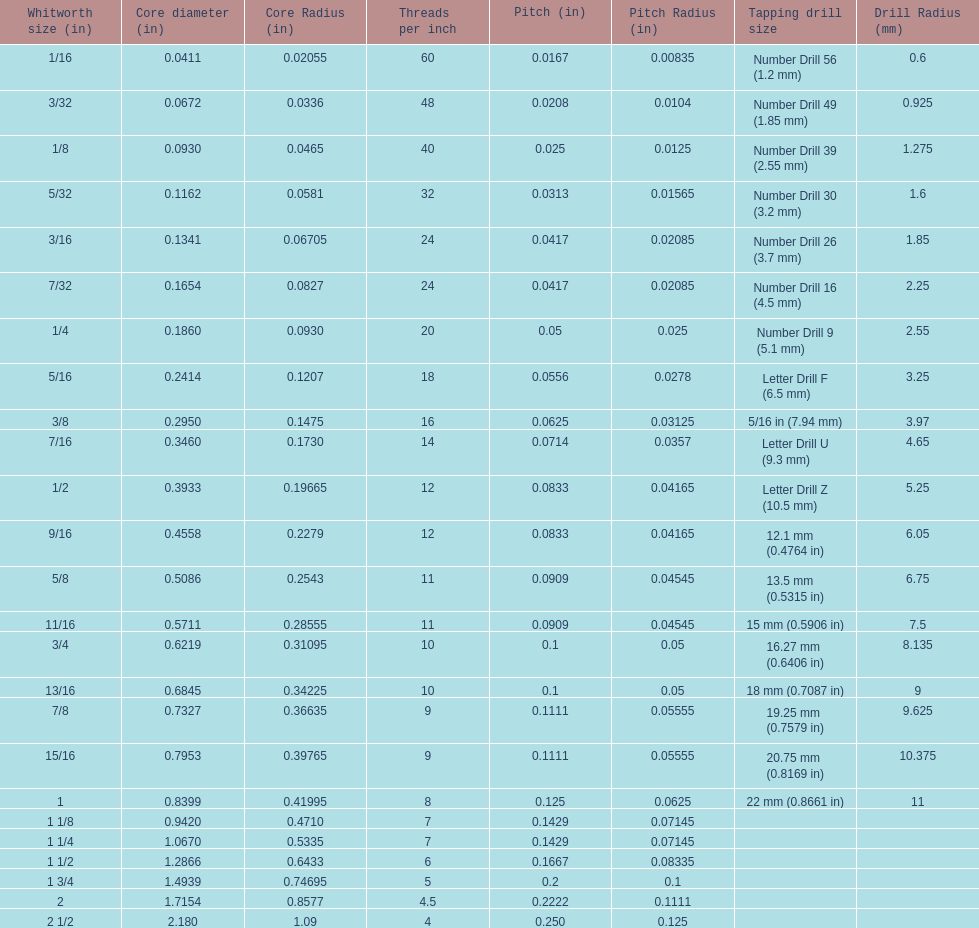Which single whitworth size features 5 threads per inch? 1 3/4. 